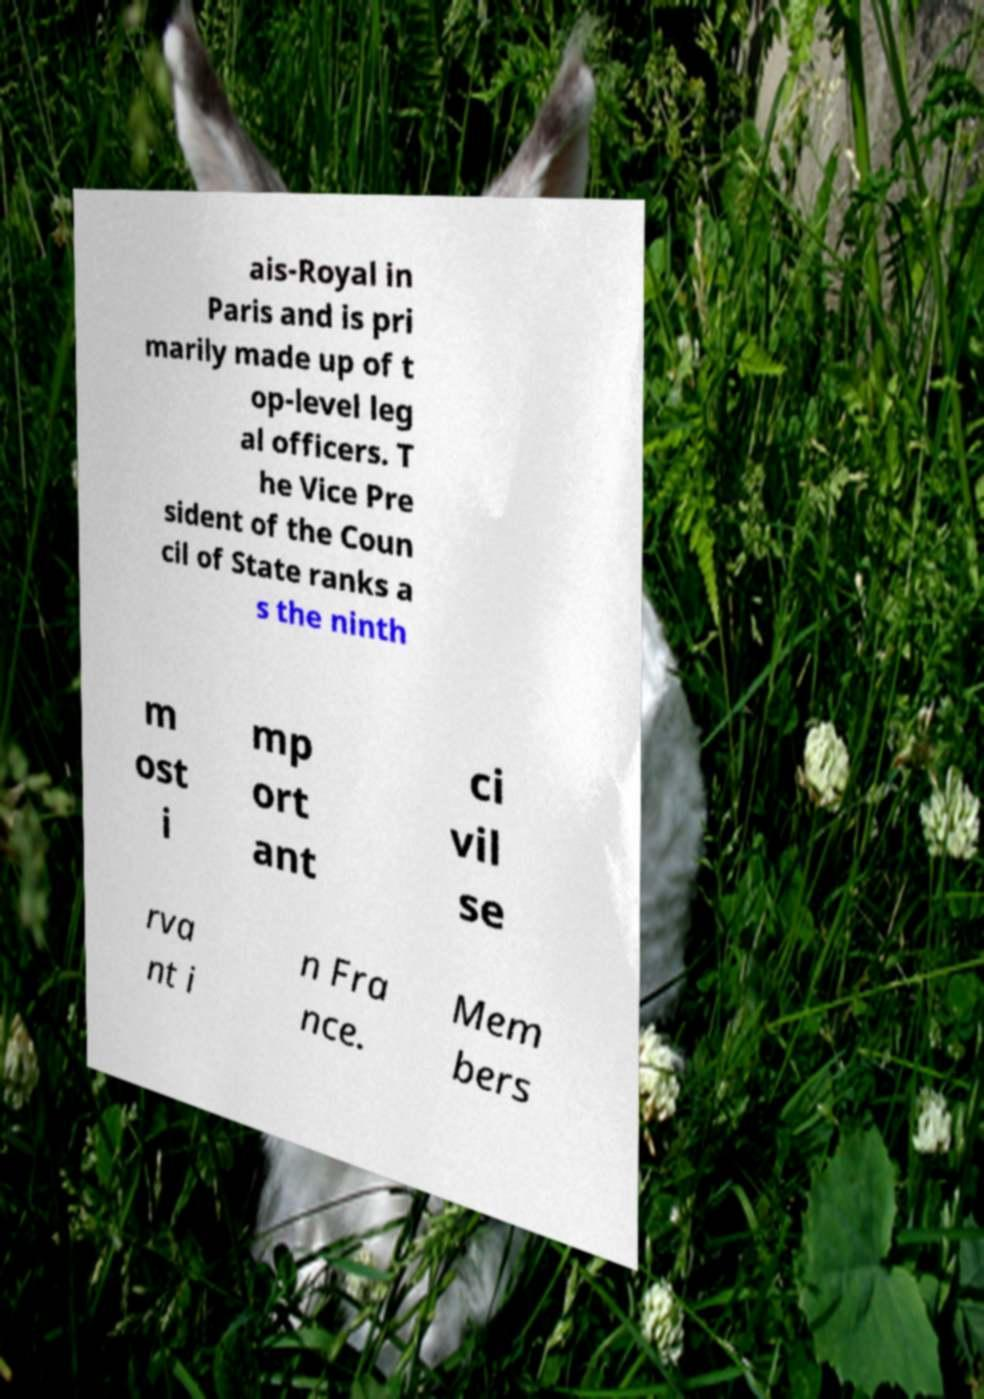There's text embedded in this image that I need extracted. Can you transcribe it verbatim? ais-Royal in Paris and is pri marily made up of t op-level leg al officers. T he Vice Pre sident of the Coun cil of State ranks a s the ninth m ost i mp ort ant ci vil se rva nt i n Fra nce. Mem bers 